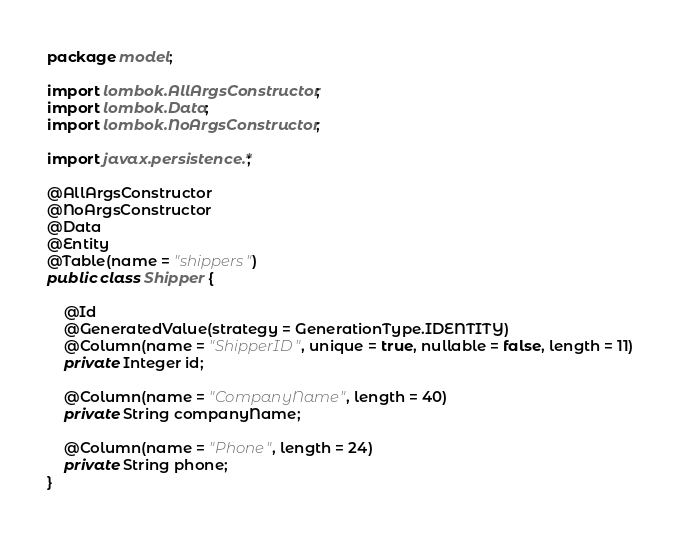<code> <loc_0><loc_0><loc_500><loc_500><_Java_>package model;

import lombok.AllArgsConstructor;
import lombok.Data;
import lombok.NoArgsConstructor;

import javax.persistence.*;

@AllArgsConstructor
@NoArgsConstructor
@Data
@Entity
@Table(name = "shippers")
public class Shipper {

    @Id
    @GeneratedValue(strategy = GenerationType.IDENTITY)
    @Column(name = "ShipperID", unique = true, nullable = false, length = 11)
    private Integer id;

    @Column(name = "CompanyName", length = 40)
    private String companyName;

    @Column(name = "Phone", length = 24)
    private String phone;
}
</code> 